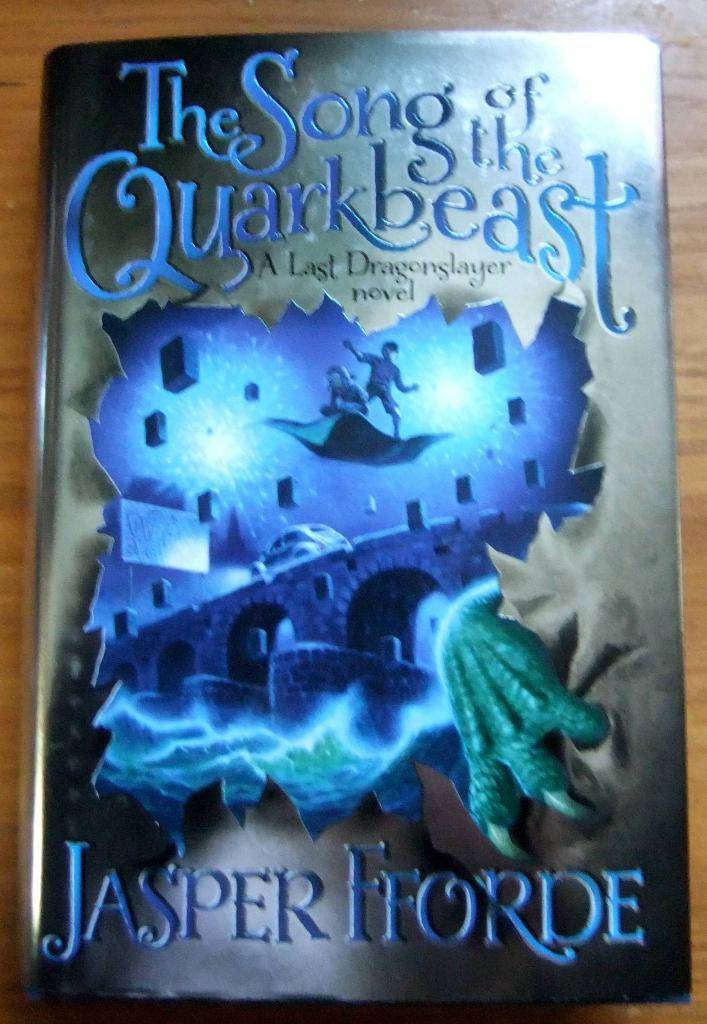<image>
Create a compact narrative representing the image presented. A book by the author Jasper Fforde has a blue cover. 